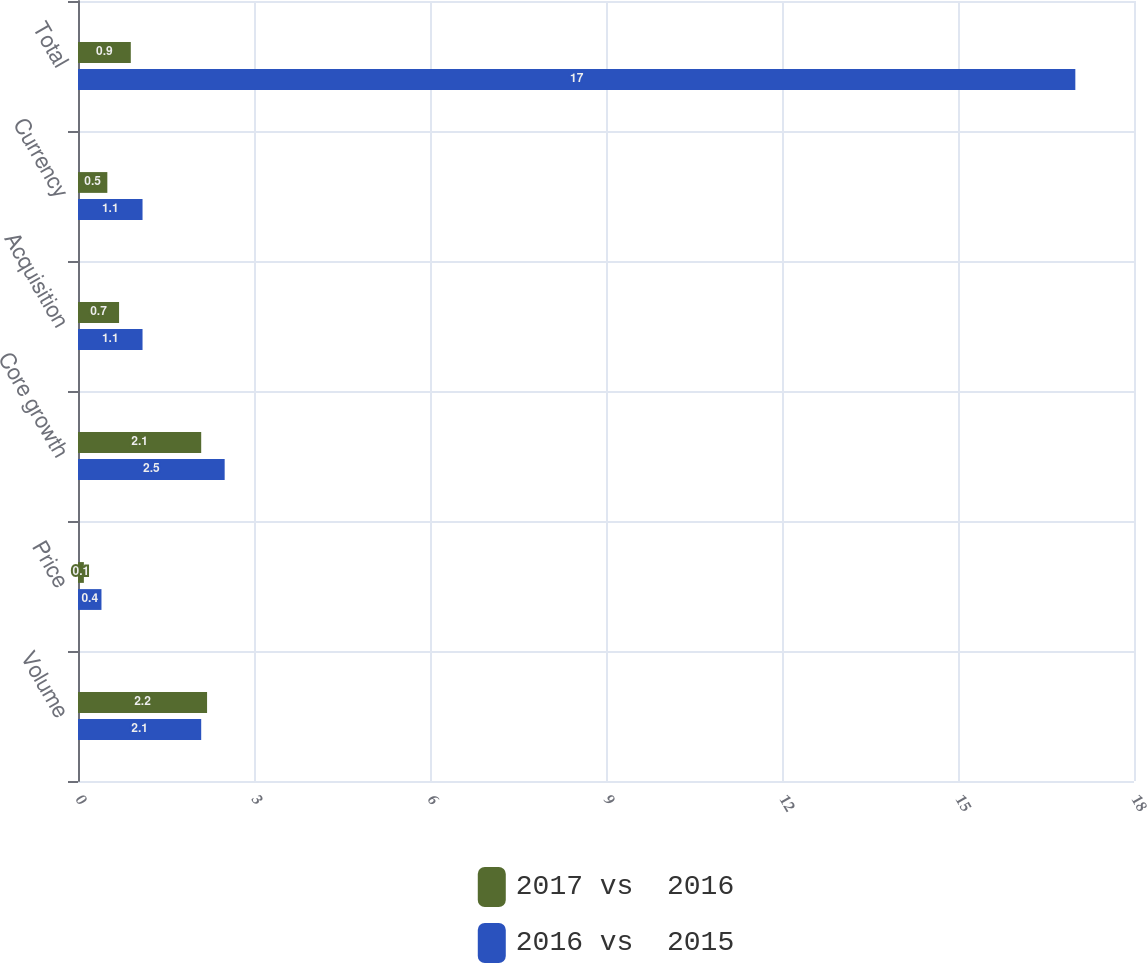Convert chart to OTSL. <chart><loc_0><loc_0><loc_500><loc_500><stacked_bar_chart><ecel><fcel>Volume<fcel>Price<fcel>Core growth<fcel>Acquisition<fcel>Currency<fcel>Total<nl><fcel>2017 vs  2016<fcel>2.2<fcel>0.1<fcel>2.1<fcel>0.7<fcel>0.5<fcel>0.9<nl><fcel>2016 vs  2015<fcel>2.1<fcel>0.4<fcel>2.5<fcel>1.1<fcel>1.1<fcel>17<nl></chart> 